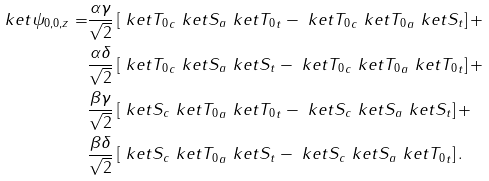<formula> <loc_0><loc_0><loc_500><loc_500>\ k e t { \psi _ { 0 , 0 , z } } = & \frac { \alpha \gamma } { \sqrt { 2 } } \left [ \ k e t { T _ { 0 } } _ { c } \ k e t { S } _ { a } \ k e t { T _ { 0 } } _ { t } - \ k e t { T _ { 0 } } _ { c } \ k e t { T _ { 0 } } _ { a } \ k e t { S } _ { t } \right ] + \\ & \frac { \alpha \delta } { \sqrt { 2 } } \left [ \ k e t { T _ { 0 } } _ { c } \ k e t { S } _ { a } \ k e t { S } _ { t } - \ k e t { T _ { 0 } } _ { c } \ k e t { T _ { 0 } } _ { a } \ k e t { T _ { 0 } } _ { t } \right ] + \\ & \frac { \beta \gamma } { \sqrt { 2 } } \left [ \ k e t { S } _ { c } \ k e t { T _ { 0 } } _ { a } \ k e t { T _ { 0 } } _ { t } - \ k e t { S } _ { c } \ k e t { S } _ { a } \ k e t { S } _ { t } \right ] + \\ & \frac { \beta \delta } { \sqrt { 2 } } \left [ \ k e t { S } _ { c } \ k e t { T _ { 0 } } _ { a } \ k e t { S } _ { t } - \ k e t { S } _ { c } \ k e t { S } _ { a } \ k e t { T _ { 0 } } _ { t } \right ] .</formula> 